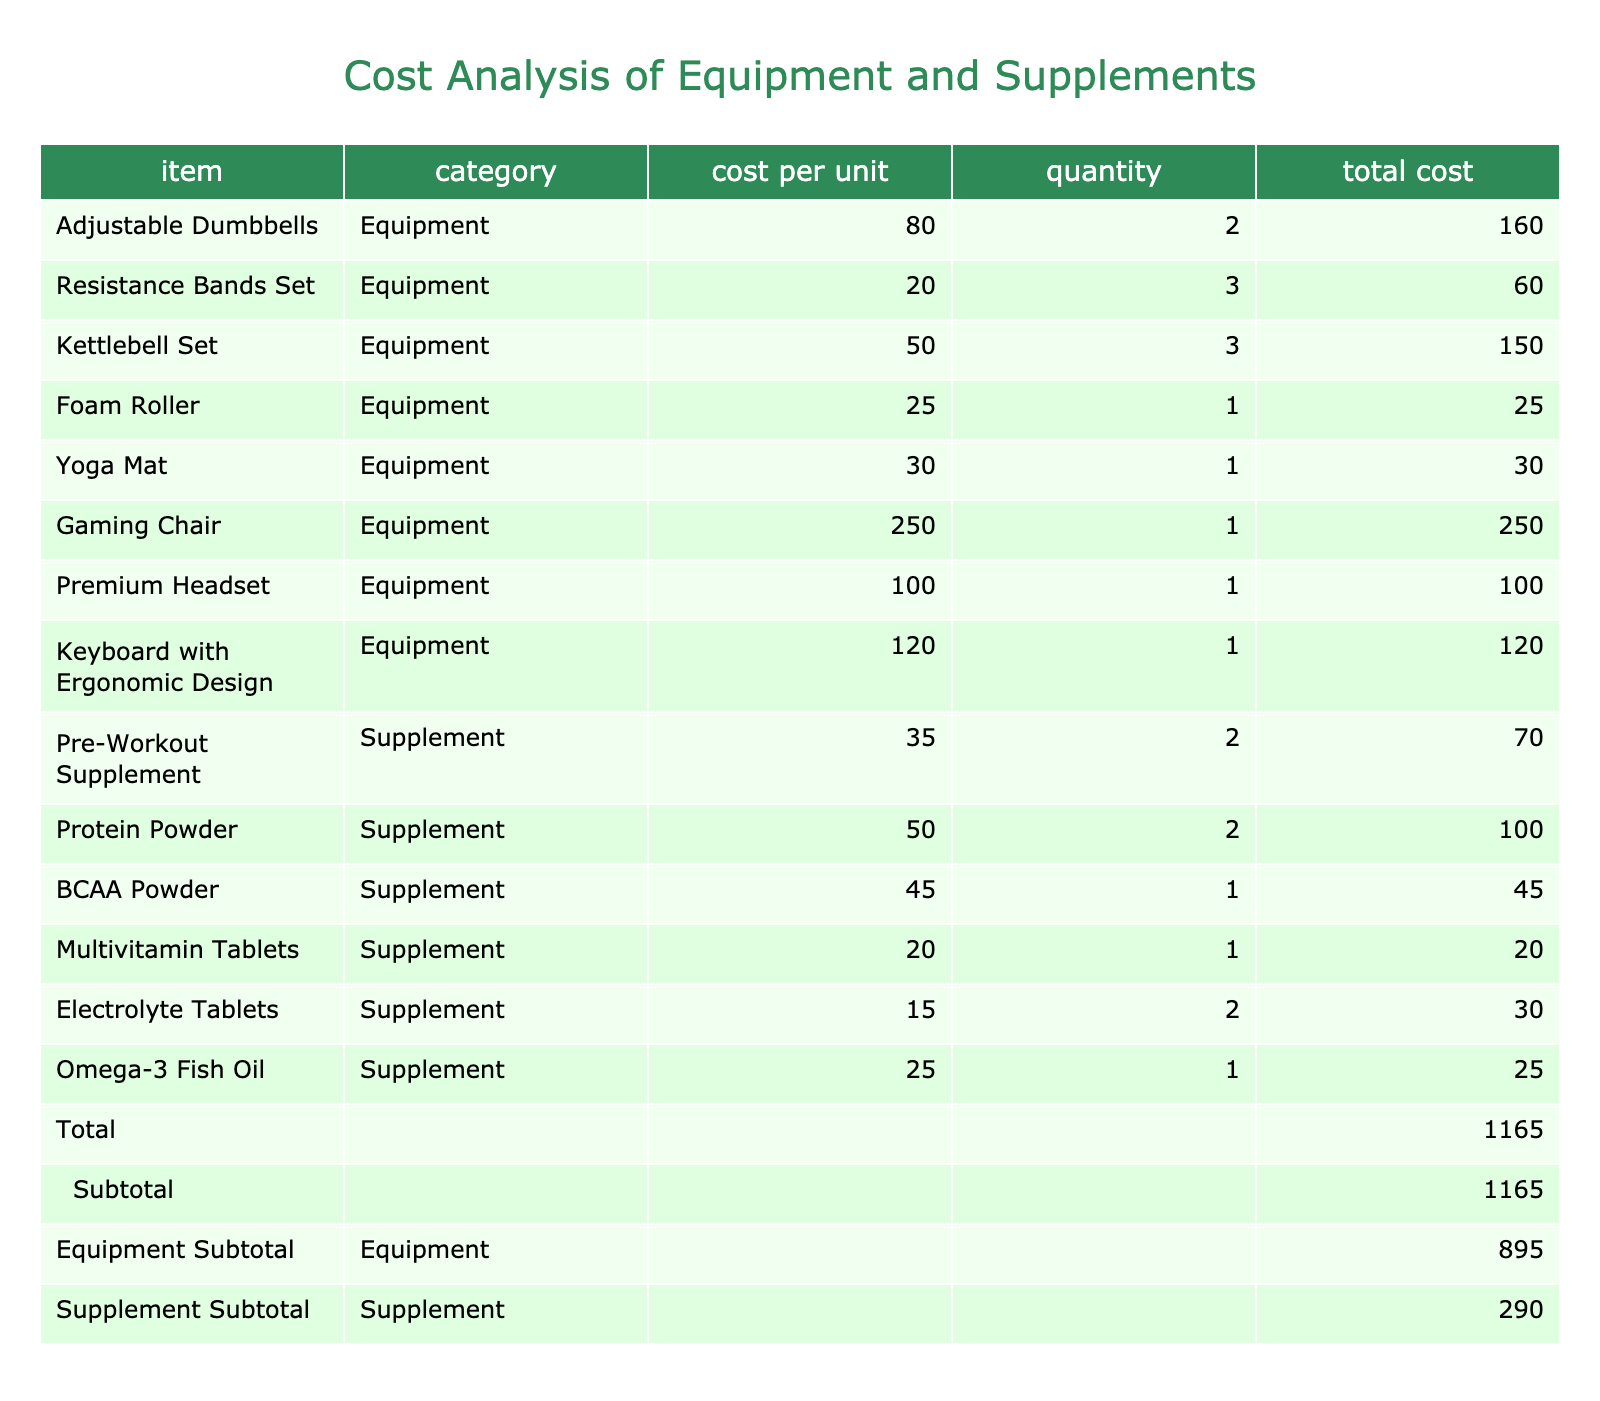What is the total cost of all equipment? To find the total cost of all equipment, I will sum the total costs from the equipment category. The equipment costs are: 160 + 60 + 150 + 25 + 30 + 250 + 100 + 120 = 795
Answer: 795 What is the total cost of supplements? To find the total cost of supplements, I will sum the total costs from the supplement category. The supplement costs are: 70 + 100 + 45 + 20 + 30 + 25 = 290
Answer: 290 How much do the adjustable dumbbells cost per unit? The cost per unit of the adjustable dumbbells is clearly listed in the table under the "cost per unit" column. It shows 80.
Answer: 80 Is the total cost of all items over 1000? The total cost of all items is provided at the bottom of the table and is equal to 1165. Since 1165 is greater than 1000, the answer is yes.
Answer: Yes What is the average cost of the supplements? To find the average cost of the supplements, I need to sum up all the total costs of the supplements and divide by the number of supplement items. The total cost is 290, and there are 6 supplements, so the average cost is 290 / 6 = 48.33 (approximately).
Answer: 48.33 Which item has the highest cost? Looking through the total costs of all items, the gaming chair has the highest cost at 250.
Answer: 250 How much more does the gaming chair cost than the yoga mat? The cost of the gaming chair is 250 and the cost of the yoga mat is 30. To find the difference, subtract the cost of the yoga mat from the gaming chair: 250 - 30 = 220.
Answer: 220 What is the total cost of resistance bands and foam roller combined? I need to find the individual total costs for the resistance bands (60) and the foam roller (25), and then add those together. So, 60 + 25 = 85.
Answer: 85 Are the total costs of BCAA powder and Omega-3 Fish Oil combined greater than the cost of the yoga mat? The total costs are 45 for the BCAA powder and 25 for the Omega-3 Fish Oil. Their combined cost is 45 + 25 = 70, and the cost of the yoga mat is 30. Since 70 is greater than 30, the answer is yes.
Answer: Yes 